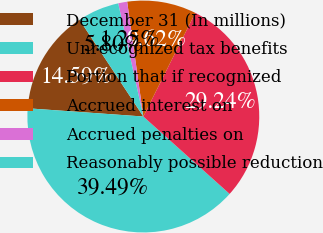<chart> <loc_0><loc_0><loc_500><loc_500><pie_chart><fcel>December 31 (In millions)<fcel>Unrecognized tax benefits<fcel>Portion that if recognized<fcel>Accrued interest on<fcel>Accrued penalties on<fcel>Reasonably possible reduction<nl><fcel>14.59%<fcel>39.49%<fcel>29.24%<fcel>9.62%<fcel>1.25%<fcel>5.8%<nl></chart> 